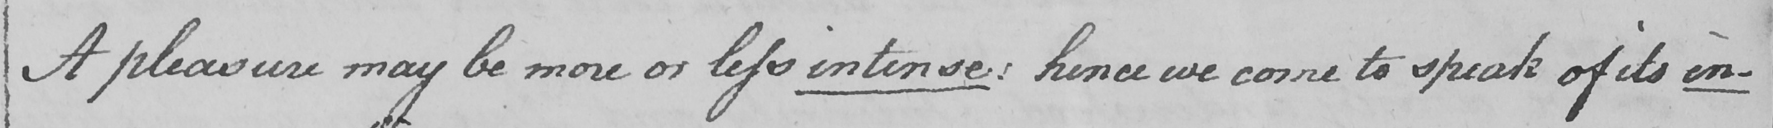Please transcribe the handwritten text in this image. A pleasure may be more or less intense :  hence we come to speak of its in- 